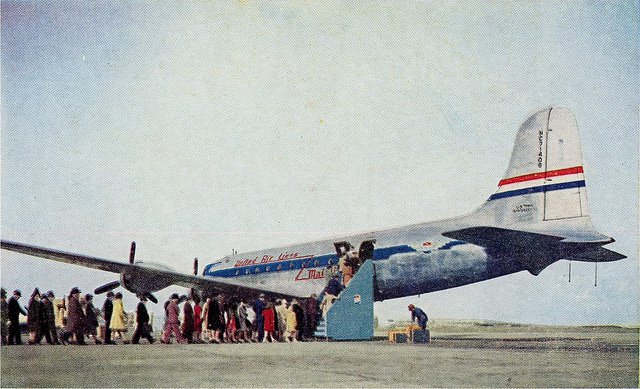Describe the objects in this image and their specific colors. I can see airplane in lightblue, darkgray, black, lightgray, and navy tones, people in lightblue, black, gray, darkgray, and maroon tones, people in lightblue, black, maroon, gray, and purple tones, people in lightblue, black, maroon, gray, and purple tones, and people in lightblue, khaki, tan, and black tones in this image. 